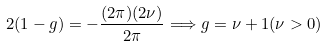<formula> <loc_0><loc_0><loc_500><loc_500>2 ( 1 - g ) = - \frac { ( 2 \pi ) ( 2 \nu ) } { 2 \pi } \Longrightarrow g = \nu + 1 ( \nu > 0 )</formula> 